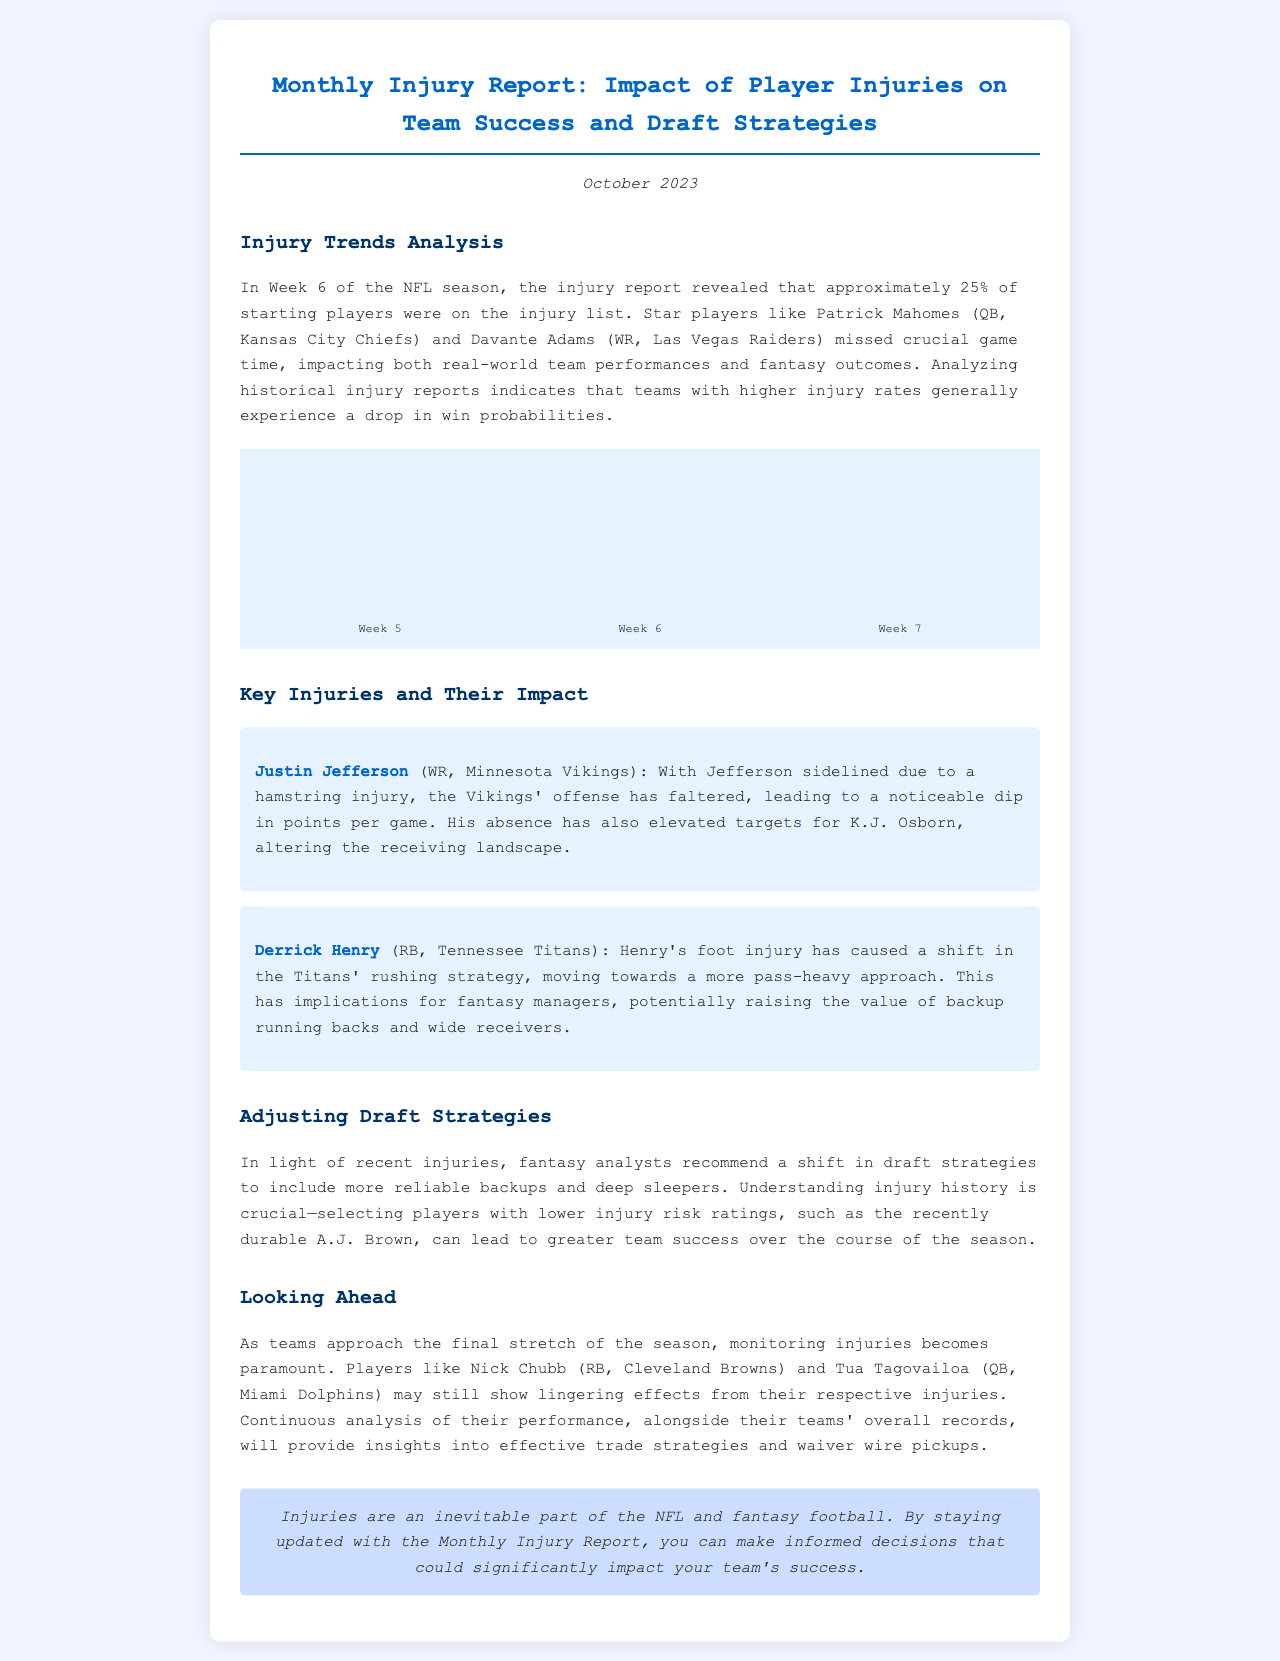What percentage of starting players were on the injury list in Week 6? The document mentions that approximately 25% of starting players were on the injury list in Week 6.
Answer: 25% Which player missed crucial game time for the Kansas City Chiefs? The document specifies that Patrick Mahomes missed crucial game time for the Chiefs.
Answer: Patrick Mahomes What impact did Justin Jefferson’s injury have on the Vikings? The document states that Jefferson's absence led to a noticeable dip in points per game for the Vikings.
Answer: Dip in points per game What is the recommendation for draft strategies mentioned in the document? The newsletter suggests shifting draft strategies to include more reliable backups and deep sleepers.
Answer: More reliable backups Which team did Derrick Henry play for? The document identifies Derrick Henry as playing for the Tennessee Titans.
Answer: Tennessee Titans What type of analysis is crucial according to the document? The newsletter emphasizes the importance of understanding injury history for better drafting decisions.
Answer: Understanding injury history How many weeks are represented in the injury trends analysis chart? The chart shows three weeks of injury trends.
Answer: Three weeks What is a noted consequence of higher injury rates for teams? The document indicates that teams with higher injury rates generally experience a drop in win probabilities.
Answer: Drop in win probabilities Which two players might show lingering effects from injuries? The newsletter mentions Nick Chubb and Tua Tagovailoa as players who may show lingering effects.
Answer: Nick Chubb and Tua Tagovailoa 